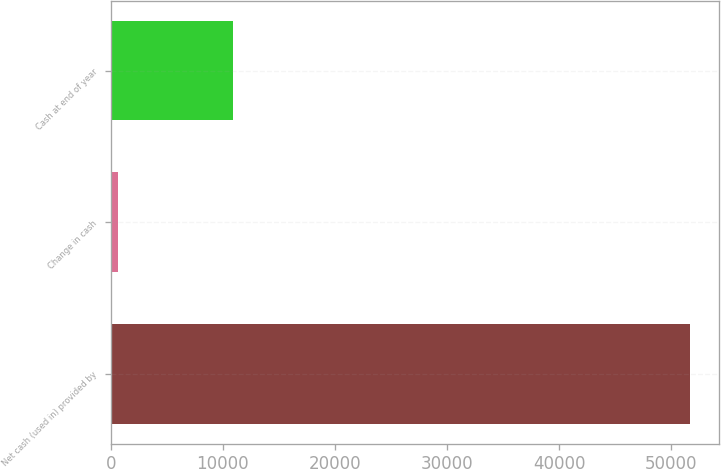Convert chart to OTSL. <chart><loc_0><loc_0><loc_500><loc_500><bar_chart><fcel>Net cash (used in) provided by<fcel>Change in cash<fcel>Cash at end of year<nl><fcel>51686<fcel>670<fcel>10873.2<nl></chart> 